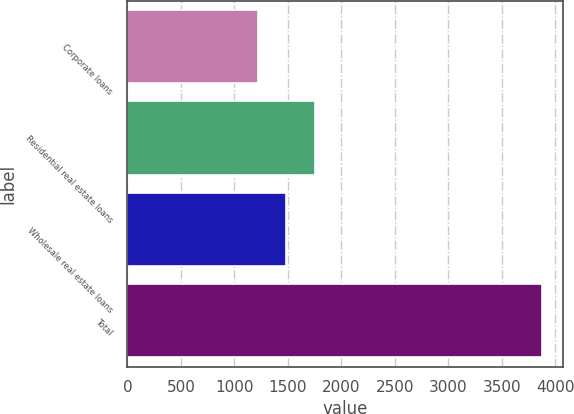Convert chart to OTSL. <chart><loc_0><loc_0><loc_500><loc_500><bar_chart><fcel>Corporate loans<fcel>Residential real estate loans<fcel>Wholesale real estate loans<fcel>Total<nl><fcel>1222<fcel>1752.4<fcel>1487.2<fcel>3874<nl></chart> 